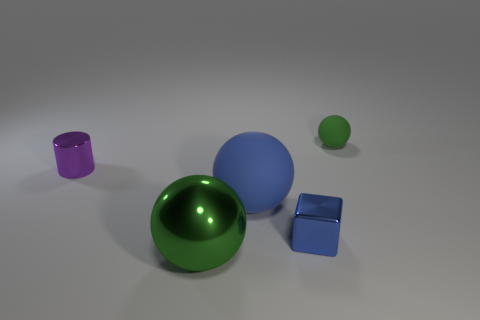Add 4 purple metal cylinders. How many objects exist? 9 Subtract all cubes. How many objects are left? 4 Add 5 large balls. How many large balls are left? 7 Add 4 blue metal blocks. How many blue metal blocks exist? 5 Subtract 0 yellow cylinders. How many objects are left? 5 Subtract all tiny cyan matte balls. Subtract all tiny green rubber spheres. How many objects are left? 4 